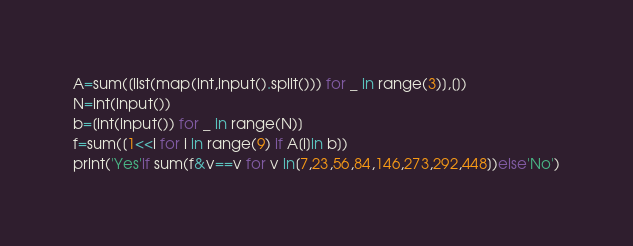<code> <loc_0><loc_0><loc_500><loc_500><_Python_>A=sum([list(map(int,input().split())) for _ in range(3)],[])
N=int(input())
b=[int(input()) for _ in range(N)]
f=sum([1<<i for i in range(9) if A[i]in b])
print('Yes'if sum(f&v==v for v in[7,23,56,84,146,273,292,448])else'No')</code> 